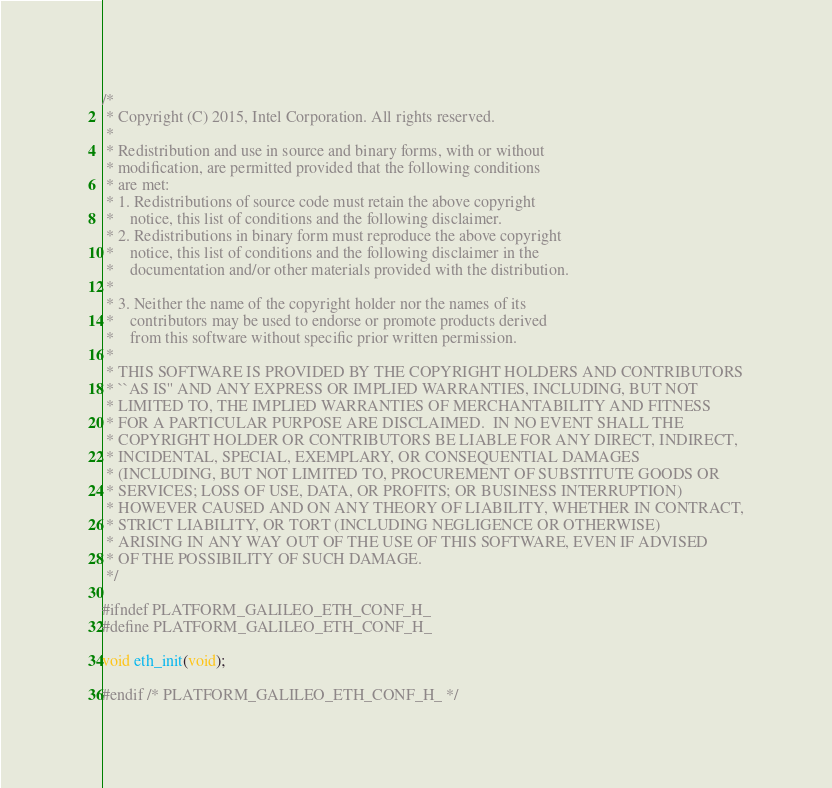Convert code to text. <code><loc_0><loc_0><loc_500><loc_500><_C_>/*
 * Copyright (C) 2015, Intel Corporation. All rights reserved.
 *
 * Redistribution and use in source and binary forms, with or without
 * modification, are permitted provided that the following conditions
 * are met:
 * 1. Redistributions of source code must retain the above copyright
 *    notice, this list of conditions and the following disclaimer.
 * 2. Redistributions in binary form must reproduce the above copyright
 *    notice, this list of conditions and the following disclaimer in the
 *    documentation and/or other materials provided with the distribution.
 *
 * 3. Neither the name of the copyright holder nor the names of its
 *    contributors may be used to endorse or promote products derived
 *    from this software without specific prior written permission.
 *
 * THIS SOFTWARE IS PROVIDED BY THE COPYRIGHT HOLDERS AND CONTRIBUTORS
 * ``AS IS'' AND ANY EXPRESS OR IMPLIED WARRANTIES, INCLUDING, BUT NOT
 * LIMITED TO, THE IMPLIED WARRANTIES OF MERCHANTABILITY AND FITNESS
 * FOR A PARTICULAR PURPOSE ARE DISCLAIMED.  IN NO EVENT SHALL THE
 * COPYRIGHT HOLDER OR CONTRIBUTORS BE LIABLE FOR ANY DIRECT, INDIRECT,
 * INCIDENTAL, SPECIAL, EXEMPLARY, OR CONSEQUENTIAL DAMAGES
 * (INCLUDING, BUT NOT LIMITED TO, PROCUREMENT OF SUBSTITUTE GOODS OR
 * SERVICES; LOSS OF USE, DATA, OR PROFITS; OR BUSINESS INTERRUPTION)
 * HOWEVER CAUSED AND ON ANY THEORY OF LIABILITY, WHETHER IN CONTRACT,
 * STRICT LIABILITY, OR TORT (INCLUDING NEGLIGENCE OR OTHERWISE)
 * ARISING IN ANY WAY OUT OF THE USE OF THIS SOFTWARE, EVEN IF ADVISED
 * OF THE POSSIBILITY OF SUCH DAMAGE.
 */

#ifndef PLATFORM_GALILEO_ETH_CONF_H_
#define PLATFORM_GALILEO_ETH_CONF_H_

void eth_init(void);

#endif /* PLATFORM_GALILEO_ETH_CONF_H_ */
</code> 